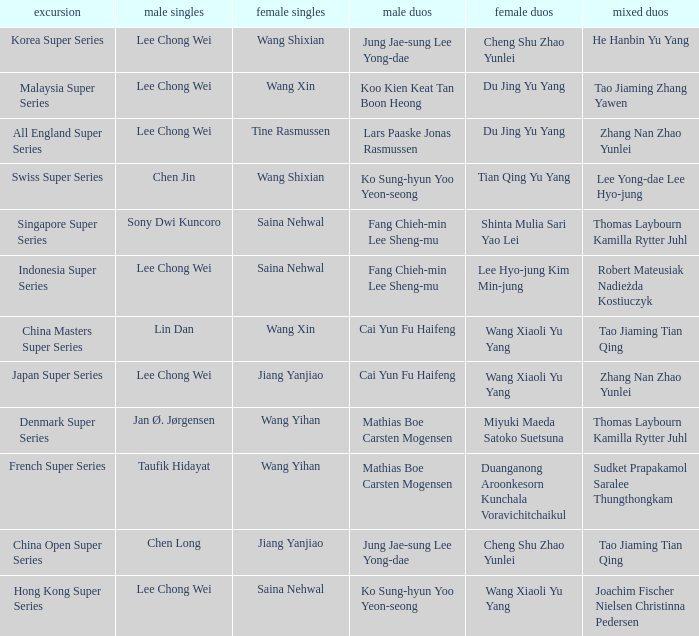Who is the mixed doubled on the tour korea super series? He Hanbin Yu Yang. 